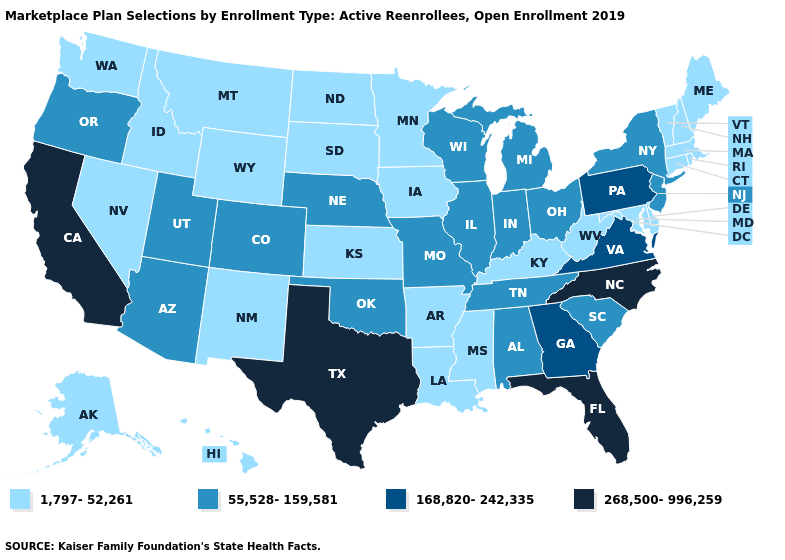Which states have the lowest value in the Northeast?
Be succinct. Connecticut, Maine, Massachusetts, New Hampshire, Rhode Island, Vermont. Is the legend a continuous bar?
Be succinct. No. Which states have the lowest value in the USA?
Quick response, please. Alaska, Arkansas, Connecticut, Delaware, Hawaii, Idaho, Iowa, Kansas, Kentucky, Louisiana, Maine, Maryland, Massachusetts, Minnesota, Mississippi, Montana, Nevada, New Hampshire, New Mexico, North Dakota, Rhode Island, South Dakota, Vermont, Washington, West Virginia, Wyoming. Which states hav the highest value in the Northeast?
Concise answer only. Pennsylvania. Among the states that border Wyoming , which have the highest value?
Give a very brief answer. Colorado, Nebraska, Utah. Name the states that have a value in the range 1,797-52,261?
Concise answer only. Alaska, Arkansas, Connecticut, Delaware, Hawaii, Idaho, Iowa, Kansas, Kentucky, Louisiana, Maine, Maryland, Massachusetts, Minnesota, Mississippi, Montana, Nevada, New Hampshire, New Mexico, North Dakota, Rhode Island, South Dakota, Vermont, Washington, West Virginia, Wyoming. Name the states that have a value in the range 268,500-996,259?
Answer briefly. California, Florida, North Carolina, Texas. Which states have the lowest value in the Northeast?
Concise answer only. Connecticut, Maine, Massachusetts, New Hampshire, Rhode Island, Vermont. What is the lowest value in the Northeast?
Keep it brief. 1,797-52,261. Name the states that have a value in the range 268,500-996,259?
Concise answer only. California, Florida, North Carolina, Texas. Is the legend a continuous bar?
Give a very brief answer. No. Does the first symbol in the legend represent the smallest category?
Write a very short answer. Yes. How many symbols are there in the legend?
Give a very brief answer. 4. Name the states that have a value in the range 168,820-242,335?
Give a very brief answer. Georgia, Pennsylvania, Virginia. Among the states that border Utah , does Nevada have the lowest value?
Quick response, please. Yes. 